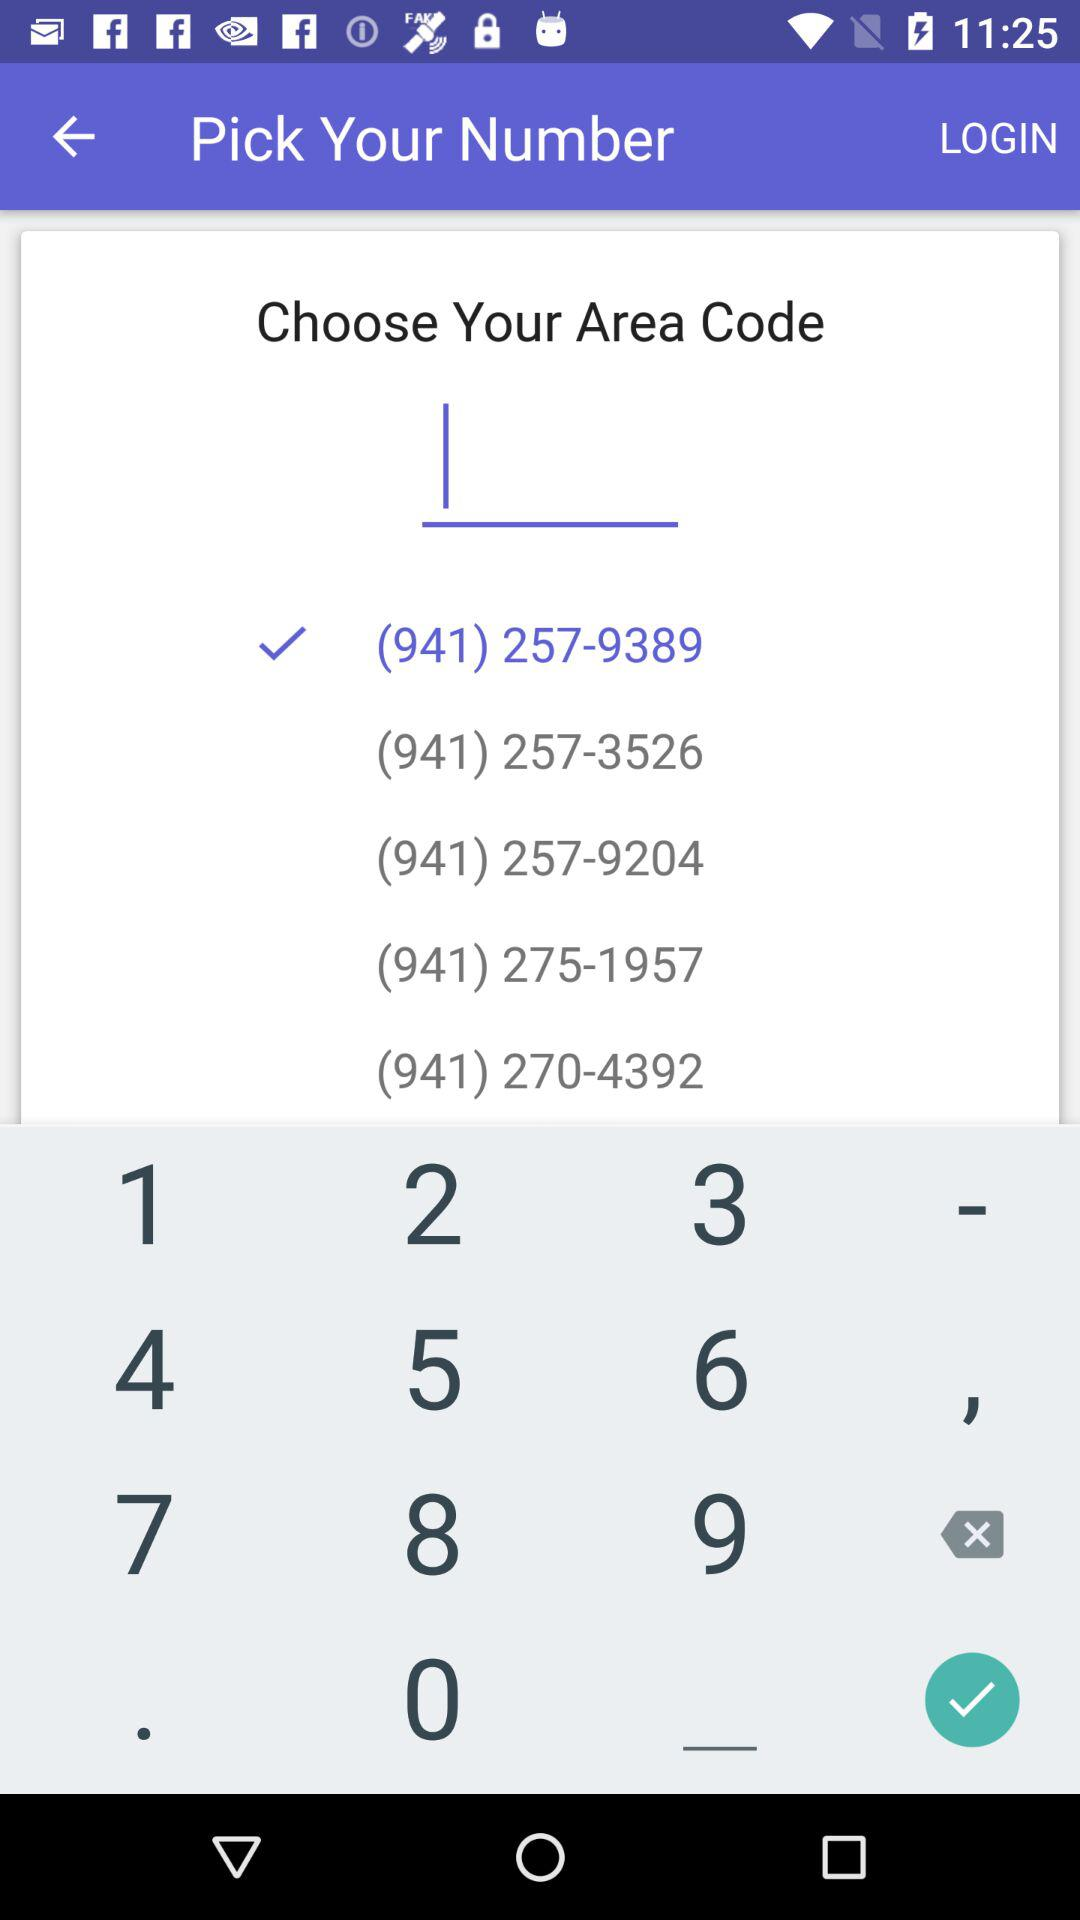What is the user's name?
When the provided information is insufficient, respond with <no answer>. <no answer> 